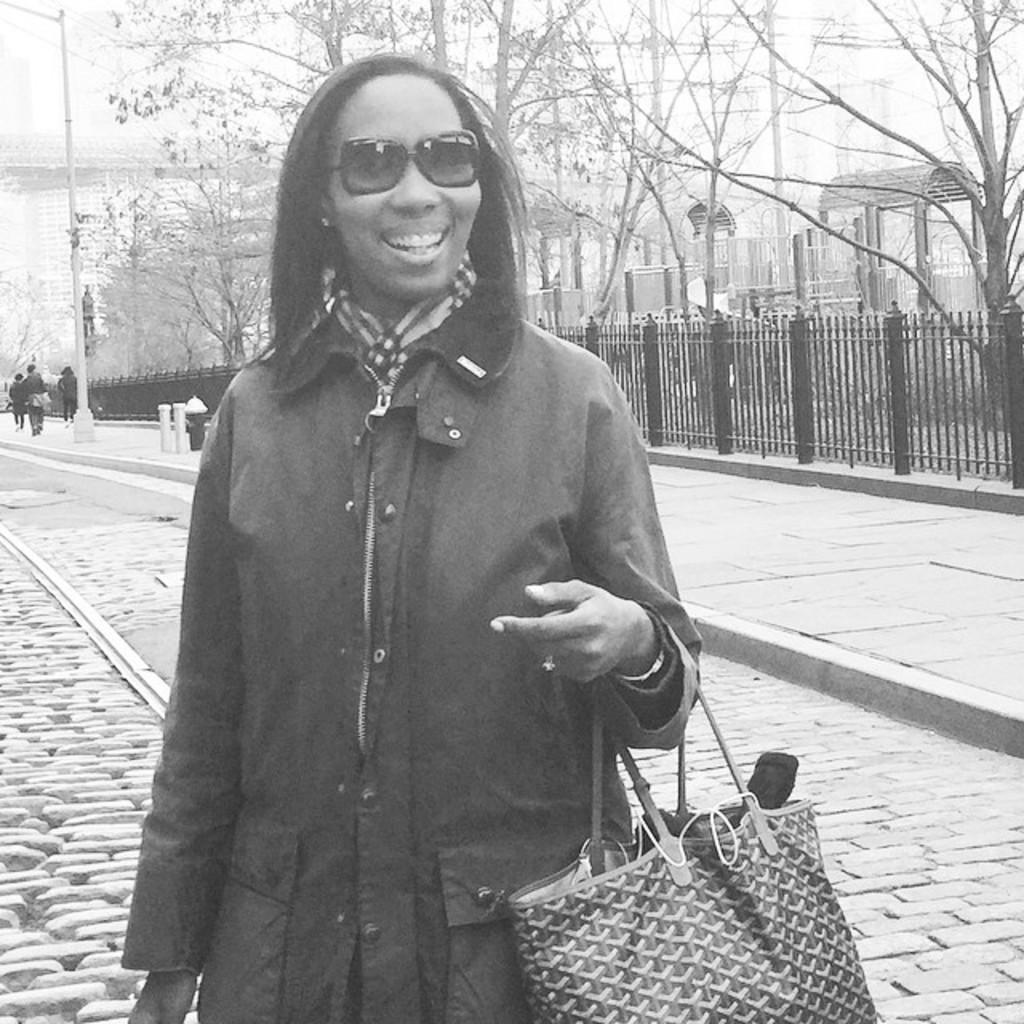Can you describe this image briefly? The image is outside of city. In the image there is a woman who is wearing her goggles and holding her bag and standing on road. On right side there is a footpath,trees and a pole. In background we can see three people are walking,buildings and sky on top. 